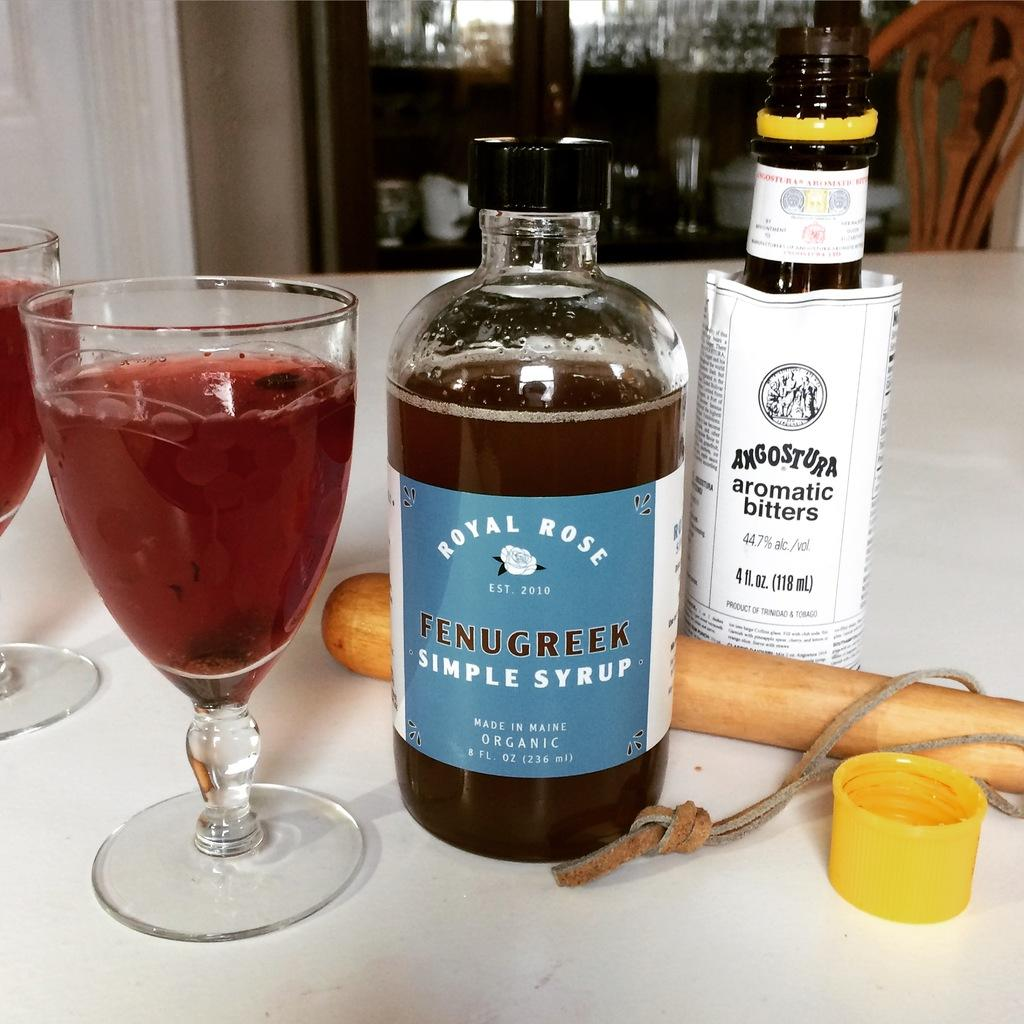What is in the glass that is visible in the image? There is a drink in the glass in the image. Where is the glass placed in the image? The glass is placed on a table in the image. What else can be seen on the table beside the glass? There are two bottles beside the glass on the table. What object is placed on the table that is not a drink container? There is a stick placed on the table in the image. What type of afterthought is depicted in the image? There is no afterthought depicted in the image; it features a glass with a drink, two bottles, and a stick on a table. Can you describe the group of animals present in the image? There are no animals present in the image; it features a glass with a drink, two bottles, and a stick on a table. 